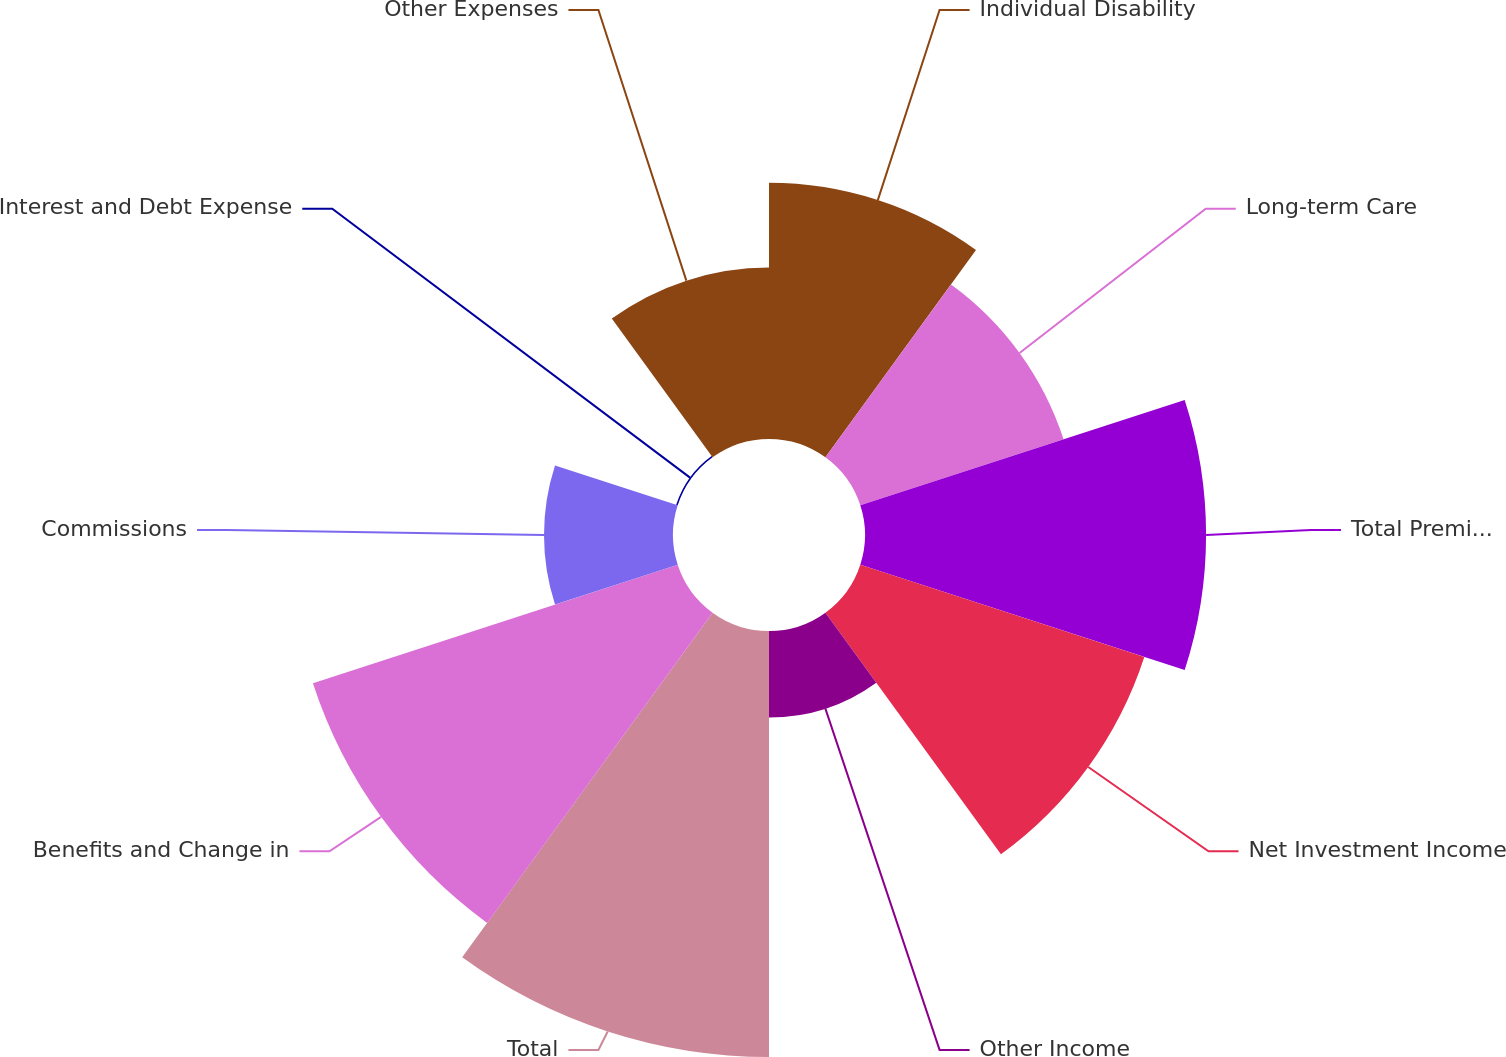Convert chart. <chart><loc_0><loc_0><loc_500><loc_500><pie_chart><fcel>Individual Disability<fcel>Long-term Care<fcel>Total Premium Income<fcel>Net Investment Income<fcel>Other Income<fcel>Total<fcel>Benefits and Change in<fcel>Commissions<fcel>Interest and Debt Expense<fcel>Other Expenses<nl><fcel>11.1%<fcel>9.26%<fcel>14.78%<fcel>12.94%<fcel>3.75%<fcel>18.46%<fcel>16.62%<fcel>5.59%<fcel>0.07%<fcel>7.43%<nl></chart> 